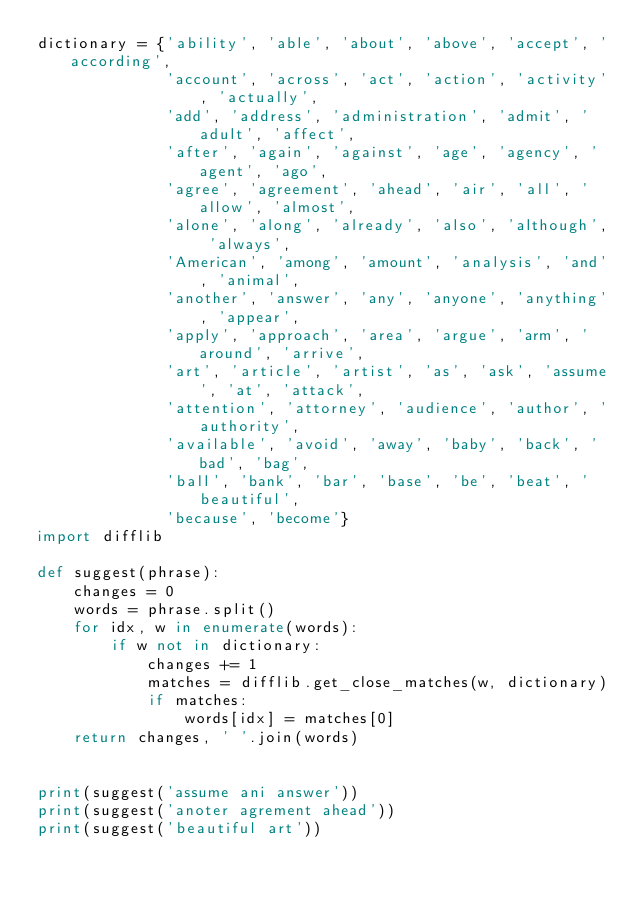<code> <loc_0><loc_0><loc_500><loc_500><_Python_>dictionary = {'ability', 'able', 'about', 'above', 'accept', 'according',
              'account', 'across', 'act', 'action', 'activity', 'actually',
              'add', 'address', 'administration', 'admit', 'adult', 'affect',
              'after', 'again', 'against', 'age', 'agency', 'agent', 'ago',
              'agree', 'agreement', 'ahead', 'air', 'all', 'allow', 'almost',
              'alone', 'along', 'already', 'also', 'although', 'always',
              'American', 'among', 'amount', 'analysis', 'and', 'animal',
              'another', 'answer', 'any', 'anyone', 'anything', 'appear',
              'apply', 'approach', 'area', 'argue', 'arm', 'around', 'arrive',
              'art', 'article', 'artist', 'as', 'ask', 'assume', 'at', 'attack',
              'attention', 'attorney', 'audience', 'author', 'authority',
              'available', 'avoid', 'away', 'baby', 'back', 'bad', 'bag',
              'ball', 'bank', 'bar', 'base', 'be', 'beat', 'beautiful',
              'because', 'become'}
import difflib

def suggest(phrase):
    changes = 0
    words = phrase.split()
    for idx, w in enumerate(words):
        if w not in dictionary:
            changes += 1
            matches = difflib.get_close_matches(w, dictionary)
            if matches:
                words[idx] = matches[0]
    return changes, ' '.join(words)


print(suggest('assume ani answer'))
print(suggest('anoter agrement ahead'))
print(suggest('beautiful art'))
</code> 